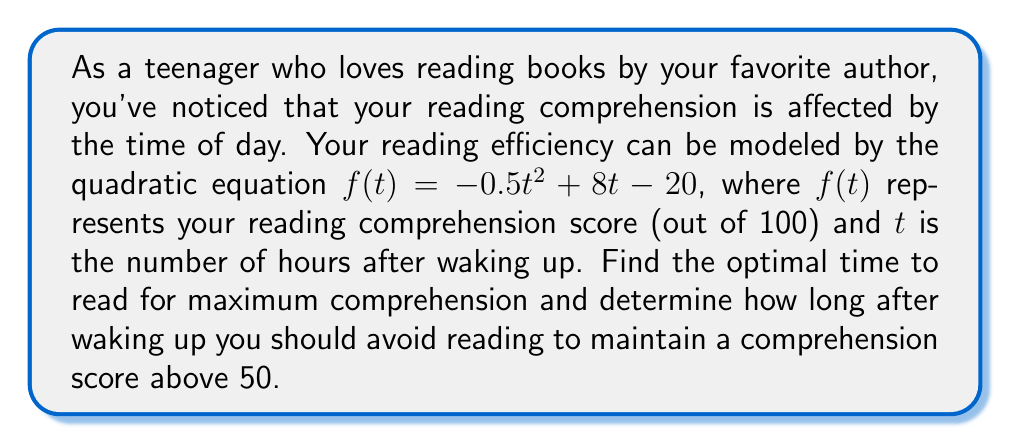Solve this math problem. To solve this problem, we need to find the roots of the quadratic equation and its vertex.

1. Find the vertex of the parabola:
   The vertex form of a quadratic equation is $f(t) = a(t-h)^2 + k$, where $(h,k)$ is the vertex.
   For $f(t) = -0.5t^2 + 8t - 20$, $a = -0.5$
   
   $h = -\frac{b}{2a} = -\frac{8}{2(-0.5)} = 8$
   
   $k = f(h) = -0.5(8)^2 + 8(8) - 20 = -32 + 64 - 20 = 12$
   
   The vertex is $(8, 12)$, meaning the optimal reading time is 8 hours after waking up.

2. Find the roots of the equation $f(t) = 50$:
   $-0.5t^2 + 8t - 20 = 50$
   $-0.5t^2 + 8t - 70 = 0$
   
   Using the quadratic formula: $t = \frac{-b \pm \sqrt{b^2 - 4ac}}{2a}$
   
   $t = \frac{-8 \pm \sqrt{8^2 - 4(-0.5)(-70)}}{2(-0.5)}$
   
   $t = \frac{-8 \pm \sqrt{64 - 140}}{-1} = \frac{-8 \pm \sqrt{-76}}{-1}$
   
   $t = \frac{-8 \pm i\sqrt{76}}{-1}$
   
   Since we're dealing with real time, there are no real roots. This means your comprehension score is always above 50.

3. To find when to avoid reading, we need to solve $f(t) = 0$:
   $-0.5t^2 + 8t - 20 = 0$
   
   Using the quadratic formula again:
   
   $t = \frac{-8 \pm \sqrt{8^2 - 4(-0.5)(-20)}}{2(-0.5)}$
   
   $t = \frac{-8 \pm \sqrt{64 + 40}}{-1} = \frac{-8 \pm \sqrt{104}}{-1}$
   
   $t = \frac{-8 \pm 10.2}{-1}$
   
   $t_1 = \frac{-8 - 10.2}{-1} = 18.2$
   $t_2 = \frac{-8 + 10.2}{-1} = -2.2$
   
   Since negative time doesn't make sense in this context, we can disregard $t_2$.
Answer: The optimal time to read for maximum comprehension is 8 hours after waking up. Your comprehension score is always above 50, so there's no need to avoid reading at any specific time. However, your reading comprehension will drop to 0 approximately 18.2 hours after waking up. 